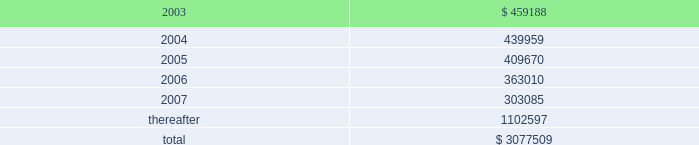American tower corporation and subsidiaries notes to consolidated financial statements 2014 ( continued ) customer leases 2014the company 2019s lease agreements with its customers vary depending upon the industry .
Television and radio broadcasters prefer long-term leases , while wireless communications providers favor leases in the range of five to ten years .
Most leases contain renewal options .
Escalation clauses present in operating leases , excluding those tied to cpi , are straight-lined over the term of the lease .
Future minimum rental receipts expected from customers under noncancelable operating lease agreements in effect at december 31 , 2002 are as follows ( in thousands ) : year ending december 31 .
Acquisition commitments 2014as of december 31 , 2002 , the company was party to an agreement relating to the acquisition of tower assets from a third party for an estimated aggregate purchase price of approximately $ 74.0 million .
The company may pursue the acquisitions of other properties and businesses in new and existing locations , although there are no definitive material agreements with respect thereto .
Build-to-suit agreements 2014as of december 31 , 2002 , the company was party to various arrangements relating to the construction of tower sites under existing build-to-suit agreements .
Under the terms of the agreements , the company is obligated to construct up to 1000 towers over a five year period which includes 650 towers in mexico and 350 towers in brazil over the next three years .
The company is in the process of renegotiating several of these agreements to reduce its overall commitment ; however , there can be no assurance that it will be successful in doing so .
Atc separation 2014the company was a wholly owned subsidiary of american radio systems corporation ( american radio ) until consummation of the spin-off of the company from american radio on june 4 , 1998 ( the atc separation ) .
On june 4 , 1998 , the merger of american radio and a subsidiary of cbs corporation ( cbs ) was consummated .
As a result of the merger , all of the outstanding shares of the company 2019s common stock owned by american radio were distributed or reserved for distribution to american radio stockholders , and the company ceased to be a subsidiary of , or to be otherwise affiliated with , american radio .
Furthermore , from that day forward the company began operating as an independent publicly traded company .
In connection with the atc separation , the company agreed to reimburse cbs for any tax liabilities incurred by american radio as a result of the transaction .
Upon completion of the final american radio tax returns , the amount of these tax liabilities was determined and paid by the company .
The company continues to be obligated under a tax indemnification agreement with cbs , however , until june 30 , 2003 , subject to the extension of federal and applicable state statutes of limitations .
The company is currently aware that the internal revenue service ( irs ) is in the process of auditing certain tax returns filed by cbs and its predecessors , including those that relate to american radio and the atc separation transaction .
In the event that the irs imposes additional tax liabilities on american radio relating to the atc separation , the company would be obligated to reimburse cbs for such liabilities .
The company cannot currently anticipate or estimate the potential additional tax liabilities , if any , that may be imposed by the irs , however , such amounts could be material to the company 2019s consolidated financial position and results of operations .
The company is not aware of any material obligations relating to this tax indemnity as of december 31 , 2002 .
Accordingly , no amounts have been provided for in the consolidated financial statements relating to this indemnification. .
As of december 312002 what was the percent of the total future minimum rental receipts due in 2004? 
Computations: (439959 / 3077509)
Answer: 0.14296. 